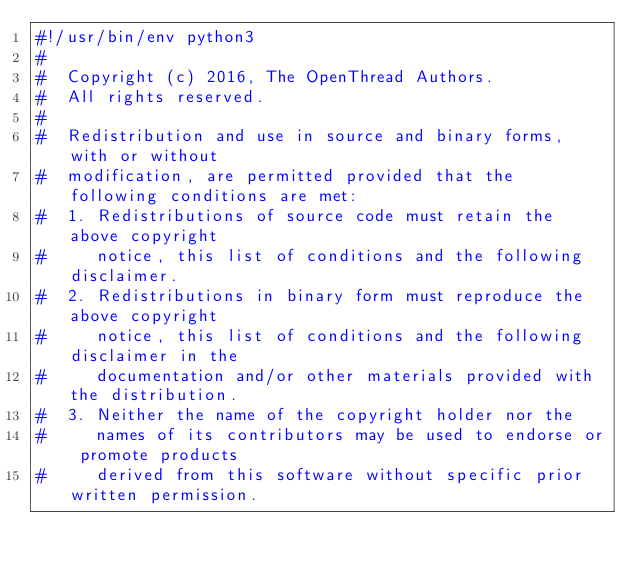Convert code to text. <code><loc_0><loc_0><loc_500><loc_500><_Python_>#!/usr/bin/env python3
#
#  Copyright (c) 2016, The OpenThread Authors.
#  All rights reserved.
#
#  Redistribution and use in source and binary forms, with or without
#  modification, are permitted provided that the following conditions are met:
#  1. Redistributions of source code must retain the above copyright
#     notice, this list of conditions and the following disclaimer.
#  2. Redistributions in binary form must reproduce the above copyright
#     notice, this list of conditions and the following disclaimer in the
#     documentation and/or other materials provided with the distribution.
#  3. Neither the name of the copyright holder nor the
#     names of its contributors may be used to endorse or promote products
#     derived from this software without specific prior written permission.</code> 